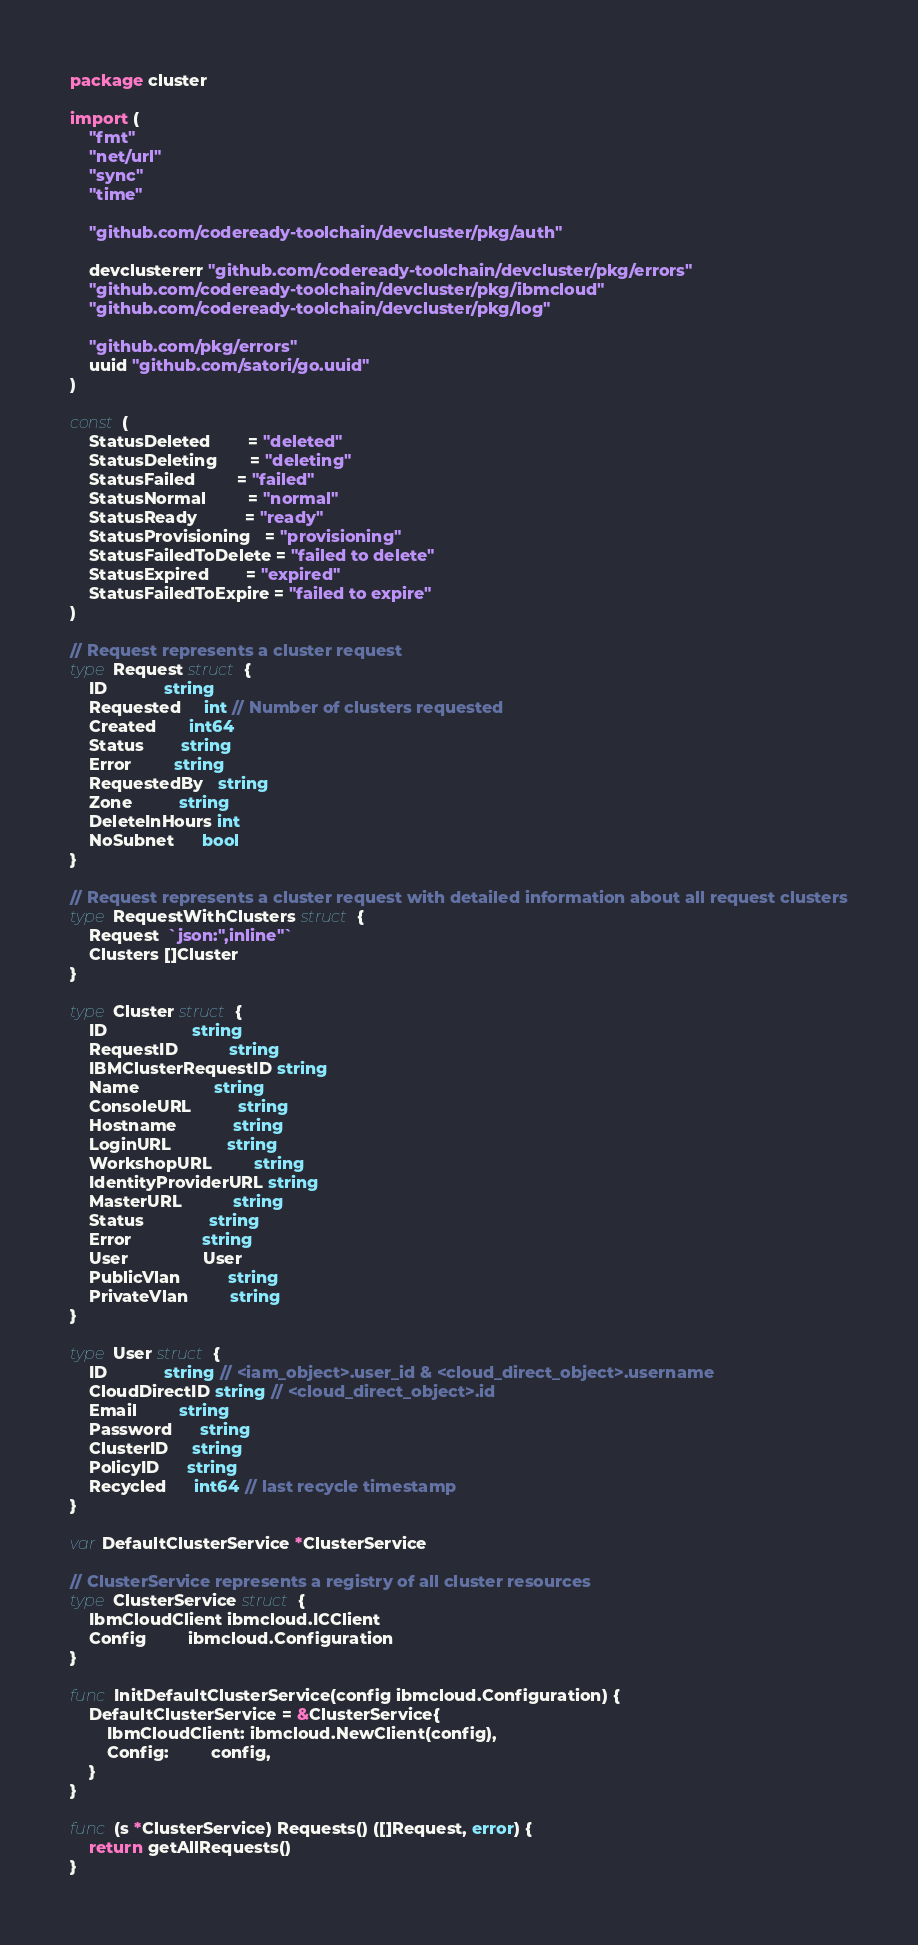Convert code to text. <code><loc_0><loc_0><loc_500><loc_500><_Go_>package cluster

import (
	"fmt"
	"net/url"
	"sync"
	"time"

	"github.com/codeready-toolchain/devcluster/pkg/auth"

	devclustererr "github.com/codeready-toolchain/devcluster/pkg/errors"
	"github.com/codeready-toolchain/devcluster/pkg/ibmcloud"
	"github.com/codeready-toolchain/devcluster/pkg/log"

	"github.com/pkg/errors"
	uuid "github.com/satori/go.uuid"
)

const (
	StatusDeleted        = "deleted"
	StatusDeleting       = "deleting"
	StatusFailed         = "failed"
	StatusNormal         = "normal"
	StatusReady          = "ready"
	StatusProvisioning   = "provisioning"
	StatusFailedToDelete = "failed to delete"
	StatusExpired        = "expired"
	StatusFailedToExpire = "failed to expire"
)

// Request represents a cluster request
type Request struct {
	ID            string
	Requested     int // Number of clusters requested
	Created       int64
	Status        string
	Error         string
	RequestedBy   string
	Zone          string
	DeleteInHours int
	NoSubnet      bool
}

// Request represents a cluster request with detailed information about all request clusters
type RequestWithClusters struct {
	Request  `json:",inline"`
	Clusters []Cluster
}

type Cluster struct {
	ID                  string
	RequestID           string
	IBMClusterRequestID string
	Name                string
	ConsoleURL          string
	Hostname            string
	LoginURL            string
	WorkshopURL         string
	IdentityProviderURL string
	MasterURL           string
	Status              string
	Error               string
	User                User
	PublicVlan          string
	PrivateVlan         string
}

type User struct {
	ID            string // <iam_object>.user_id & <cloud_direct_object>.username
	CloudDirectID string // <cloud_direct_object>.id
	Email         string
	Password      string
	ClusterID     string
	PolicyID      string
	Recycled      int64 // last recycle timestamp
}

var DefaultClusterService *ClusterService

// ClusterService represents a registry of all cluster resources
type ClusterService struct {
	IbmCloudClient ibmcloud.ICClient
	Config         ibmcloud.Configuration
}

func InitDefaultClusterService(config ibmcloud.Configuration) {
	DefaultClusterService = &ClusterService{
		IbmCloudClient: ibmcloud.NewClient(config),
		Config:         config,
	}
}

func (s *ClusterService) Requests() ([]Request, error) {
	return getAllRequests()
}
</code> 